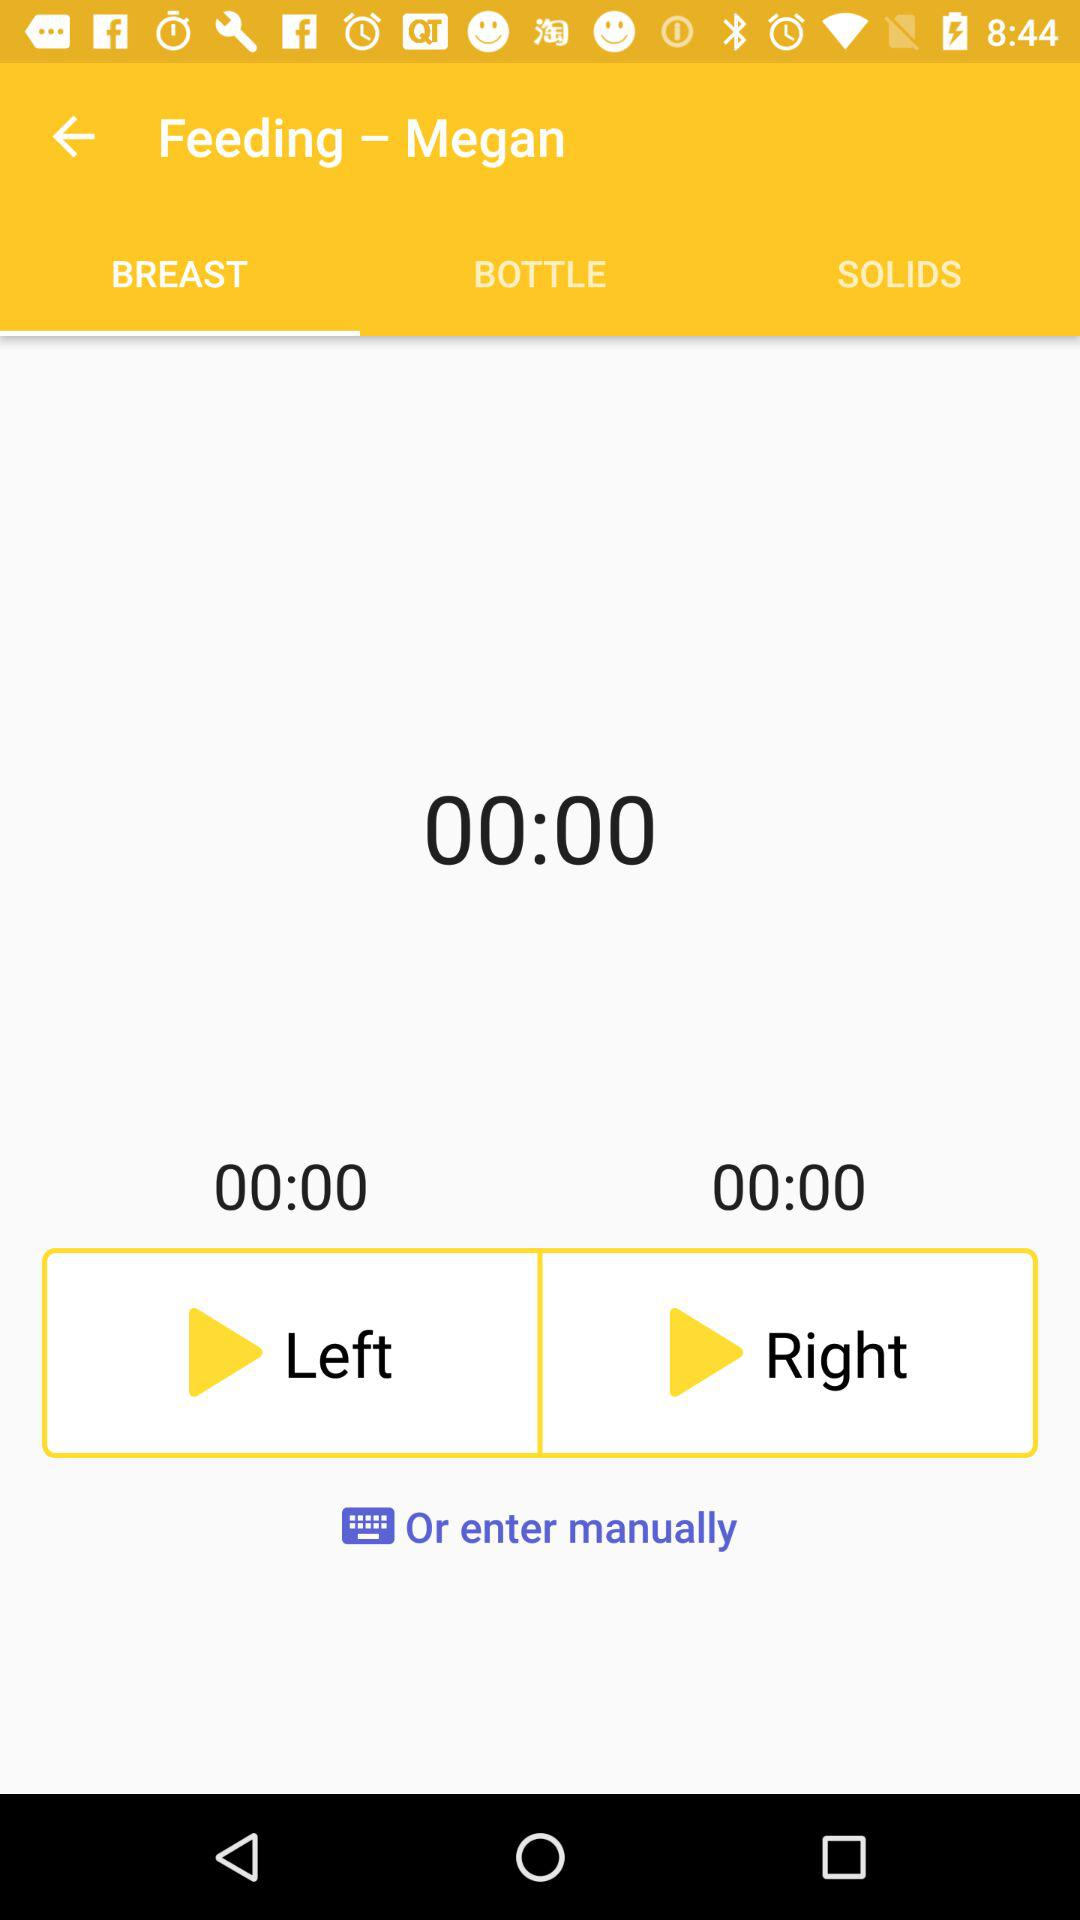What is the selected option in "Feeding – Megan"? The selected option is "BREAST". 